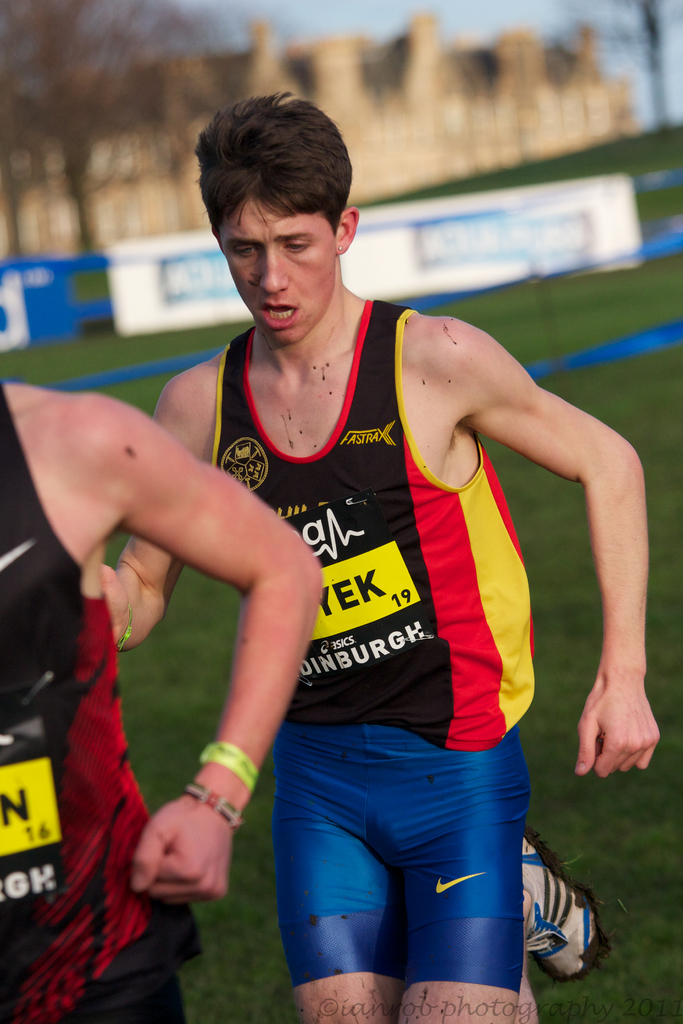Can you describe the relevance of the attire worn by the athletes in this type of event? In cross-country running, athletes wear lightweight, breathable jerseys and fitted shorts or leggings designed to provide mobility and comfort over uneven terrain. The presence of mud on their clothes and shoes indicates they are equipped for outdoor conditions where slipping and sliding might occur. The prominent branding, like 'FASTRAX' on the jersey, often represents team affiliations or sponsorships important in competitive sports for identity and support. 